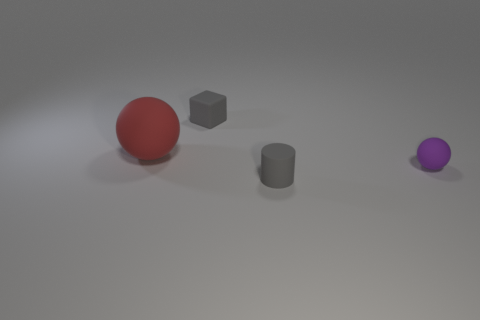What could be the purpose of these objects being placed together in this scene? The arrangement of these objects may be purely for visual or aesthetic purposes, possibly as part of a rendering test for graphic design or to demonstrate the use of shadow and light in a 3D modeled environment. They may not have a practical purpose but rather serve to showcase the artist's skill in creating lifelike textures and reflections. 